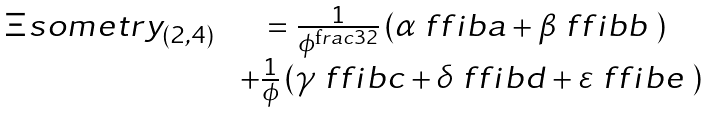Convert formula to latex. <formula><loc_0><loc_0><loc_500><loc_500>\begin{matrix} \Xi s o m e t r y _ { ( 2 , 4 ) } & = \frac { 1 } { \phi ^ { \text  frac{3} { 2 } } } \left ( \alpha \ f f i b a + \beta \ f f i b b \ \right ) \\ & \ + \frac { 1 } { \phi } \left ( \gamma \ f f i b c + \delta \ f f i b d + \varepsilon \ f f i b e \ \right ) \end{matrix}</formula> 